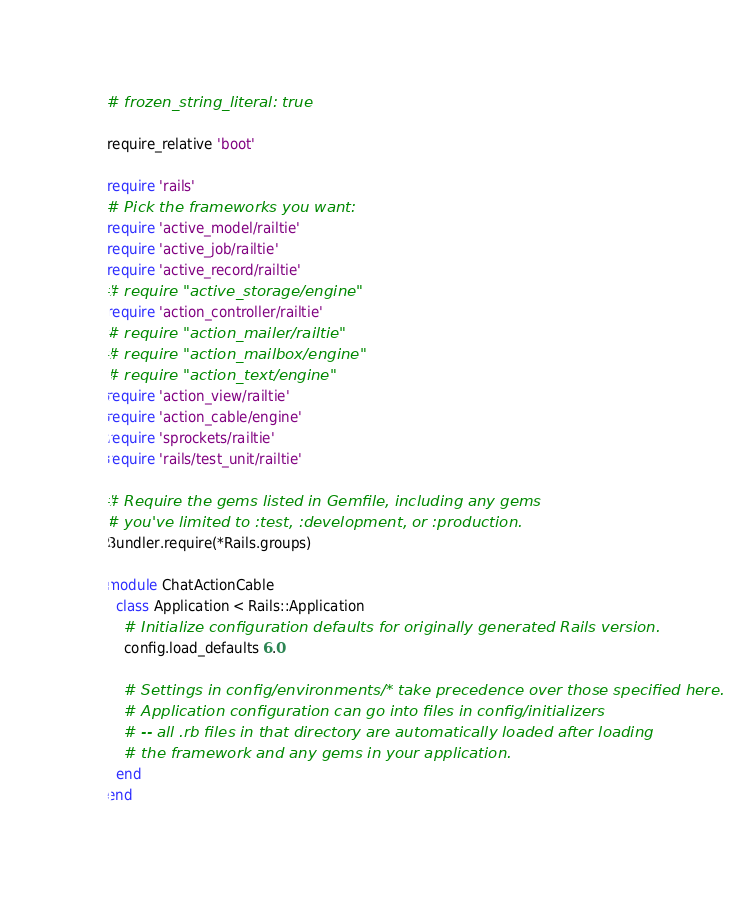<code> <loc_0><loc_0><loc_500><loc_500><_Ruby_># frozen_string_literal: true

require_relative 'boot'

require 'rails'
# Pick the frameworks you want:
require 'active_model/railtie'
require 'active_job/railtie'
require 'active_record/railtie'
# require "active_storage/engine"
require 'action_controller/railtie'
# require "action_mailer/railtie"
# require "action_mailbox/engine"
# require "action_text/engine"
require 'action_view/railtie'
require 'action_cable/engine'
require 'sprockets/railtie'
require 'rails/test_unit/railtie'

# Require the gems listed in Gemfile, including any gems
# you've limited to :test, :development, or :production.
Bundler.require(*Rails.groups)

module ChatActionCable
  class Application < Rails::Application
    # Initialize configuration defaults for originally generated Rails version.
    config.load_defaults 6.0

    # Settings in config/environments/* take precedence over those specified here.
    # Application configuration can go into files in config/initializers
    # -- all .rb files in that directory are automatically loaded after loading
    # the framework and any gems in your application.
  end
end
</code> 